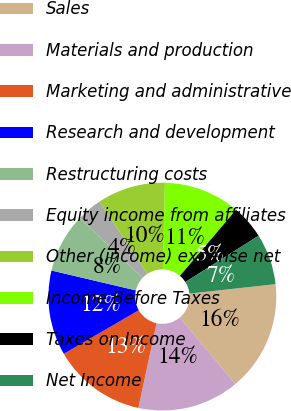Convert chart. <chart><loc_0><loc_0><loc_500><loc_500><pie_chart><fcel>Sales<fcel>Materials and production<fcel>Marketing and administrative<fcel>Research and development<fcel>Restructuring costs<fcel>Equity income from affiliates<fcel>Other (income) expense net<fcel>Income Before Taxes<fcel>Taxes on Income<fcel>Net Income<nl><fcel>15.66%<fcel>14.46%<fcel>13.25%<fcel>12.05%<fcel>8.43%<fcel>3.61%<fcel>9.64%<fcel>10.84%<fcel>4.82%<fcel>7.23%<nl></chart> 